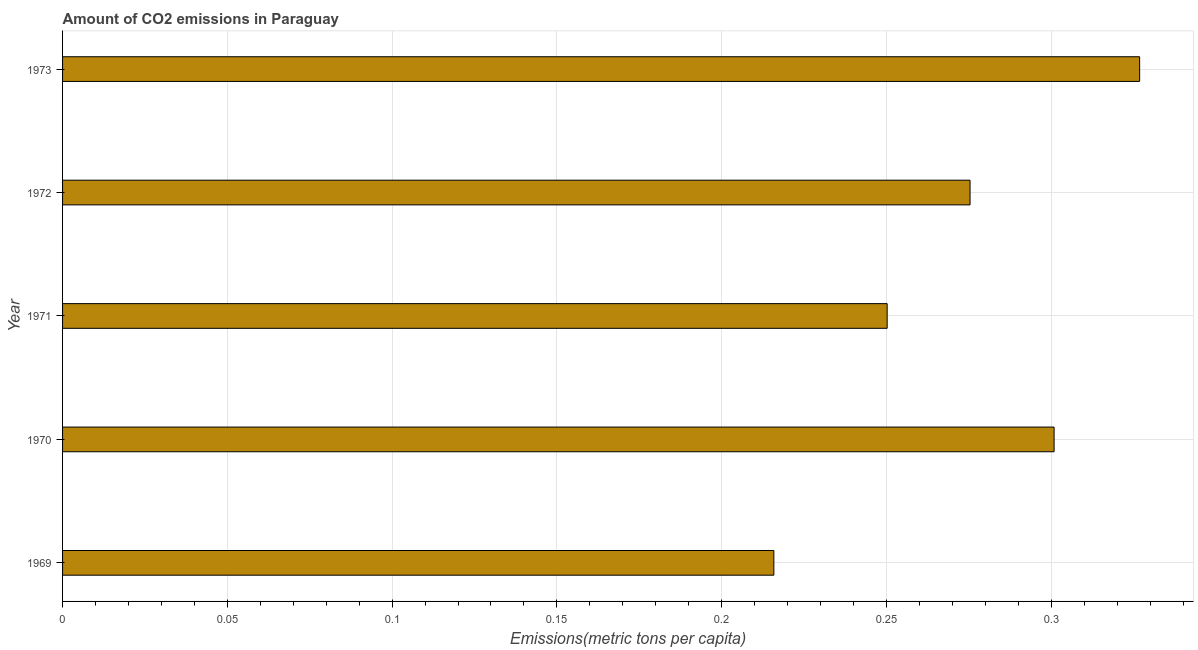Does the graph contain any zero values?
Give a very brief answer. No. What is the title of the graph?
Ensure brevity in your answer.  Amount of CO2 emissions in Paraguay. What is the label or title of the X-axis?
Make the answer very short. Emissions(metric tons per capita). What is the amount of co2 emissions in 1969?
Provide a succinct answer. 0.22. Across all years, what is the maximum amount of co2 emissions?
Give a very brief answer. 0.33. Across all years, what is the minimum amount of co2 emissions?
Your answer should be compact. 0.22. In which year was the amount of co2 emissions maximum?
Your answer should be compact. 1973. In which year was the amount of co2 emissions minimum?
Your answer should be compact. 1969. What is the sum of the amount of co2 emissions?
Offer a very short reply. 1.37. What is the difference between the amount of co2 emissions in 1969 and 1973?
Your answer should be very brief. -0.11. What is the average amount of co2 emissions per year?
Your answer should be compact. 0.27. What is the median amount of co2 emissions?
Offer a terse response. 0.28. In how many years, is the amount of co2 emissions greater than 0.05 metric tons per capita?
Make the answer very short. 5. Do a majority of the years between 1971 and 1970 (inclusive) have amount of co2 emissions greater than 0.32 metric tons per capita?
Provide a short and direct response. No. What is the ratio of the amount of co2 emissions in 1969 to that in 1973?
Provide a short and direct response. 0.66. Is the amount of co2 emissions in 1972 less than that in 1973?
Offer a terse response. Yes. What is the difference between the highest and the second highest amount of co2 emissions?
Your answer should be very brief. 0.03. Is the sum of the amount of co2 emissions in 1969 and 1972 greater than the maximum amount of co2 emissions across all years?
Ensure brevity in your answer.  Yes. What is the difference between the highest and the lowest amount of co2 emissions?
Give a very brief answer. 0.11. Are all the bars in the graph horizontal?
Ensure brevity in your answer.  Yes. What is the difference between two consecutive major ticks on the X-axis?
Ensure brevity in your answer.  0.05. What is the Emissions(metric tons per capita) of 1969?
Provide a succinct answer. 0.22. What is the Emissions(metric tons per capita) of 1970?
Provide a succinct answer. 0.3. What is the Emissions(metric tons per capita) in 1971?
Keep it short and to the point. 0.25. What is the Emissions(metric tons per capita) of 1972?
Offer a very short reply. 0.28. What is the Emissions(metric tons per capita) of 1973?
Your response must be concise. 0.33. What is the difference between the Emissions(metric tons per capita) in 1969 and 1970?
Your response must be concise. -0.09. What is the difference between the Emissions(metric tons per capita) in 1969 and 1971?
Make the answer very short. -0.03. What is the difference between the Emissions(metric tons per capita) in 1969 and 1972?
Provide a short and direct response. -0.06. What is the difference between the Emissions(metric tons per capita) in 1969 and 1973?
Make the answer very short. -0.11. What is the difference between the Emissions(metric tons per capita) in 1970 and 1971?
Offer a terse response. 0.05. What is the difference between the Emissions(metric tons per capita) in 1970 and 1972?
Offer a terse response. 0.03. What is the difference between the Emissions(metric tons per capita) in 1970 and 1973?
Your answer should be very brief. -0.03. What is the difference between the Emissions(metric tons per capita) in 1971 and 1972?
Your answer should be compact. -0.03. What is the difference between the Emissions(metric tons per capita) in 1971 and 1973?
Your answer should be very brief. -0.08. What is the difference between the Emissions(metric tons per capita) in 1972 and 1973?
Provide a short and direct response. -0.05. What is the ratio of the Emissions(metric tons per capita) in 1969 to that in 1970?
Offer a very short reply. 0.72. What is the ratio of the Emissions(metric tons per capita) in 1969 to that in 1971?
Ensure brevity in your answer.  0.86. What is the ratio of the Emissions(metric tons per capita) in 1969 to that in 1972?
Give a very brief answer. 0.78. What is the ratio of the Emissions(metric tons per capita) in 1969 to that in 1973?
Offer a terse response. 0.66. What is the ratio of the Emissions(metric tons per capita) in 1970 to that in 1971?
Keep it short and to the point. 1.2. What is the ratio of the Emissions(metric tons per capita) in 1970 to that in 1972?
Provide a succinct answer. 1.09. What is the ratio of the Emissions(metric tons per capita) in 1970 to that in 1973?
Make the answer very short. 0.92. What is the ratio of the Emissions(metric tons per capita) in 1971 to that in 1972?
Provide a succinct answer. 0.91. What is the ratio of the Emissions(metric tons per capita) in 1971 to that in 1973?
Your response must be concise. 0.77. What is the ratio of the Emissions(metric tons per capita) in 1972 to that in 1973?
Make the answer very short. 0.84. 